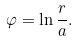<formula> <loc_0><loc_0><loc_500><loc_500>\varphi = \ln \frac { r } { a } .</formula> 